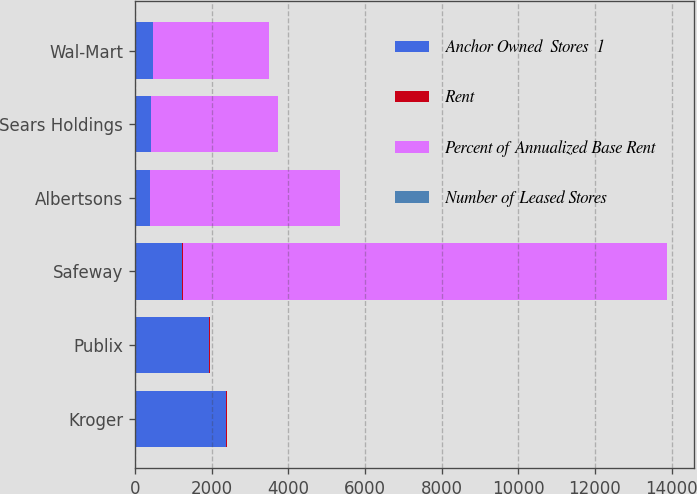<chart> <loc_0><loc_0><loc_500><loc_500><stacked_bar_chart><ecel><fcel>Kroger<fcel>Publix<fcel>Safeway<fcel>Albertsons<fcel>Sears Holdings<fcel>Wal-Mart<nl><fcel>Anchor Owned  Stores  1<fcel>2384<fcel>1940<fcel>1239<fcel>395<fcel>412<fcel>466<nl><fcel>Rent<fcel>8.6<fcel>7<fcel>4.4<fcel>1.4<fcel>1.5<fcel>1.7<nl><fcel>Percent of Annualized Base Rent<fcel>7.8<fcel>7.8<fcel>12638<fcel>4952<fcel>3315<fcel>3026<nl><fcel>Number of Leased Stores<fcel>4.7<fcel>4.3<fcel>2.7<fcel>1<fcel>0.7<fcel>0.6<nl></chart> 